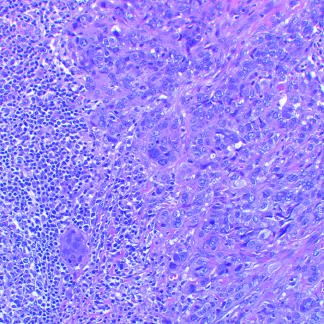do carcinomas consist of tightly adhesive clusters of cells, as in this carcinoma with medullary features, or when there is abundant extracellular mucin production?
Answer the question using a single word or phrase. Yes 